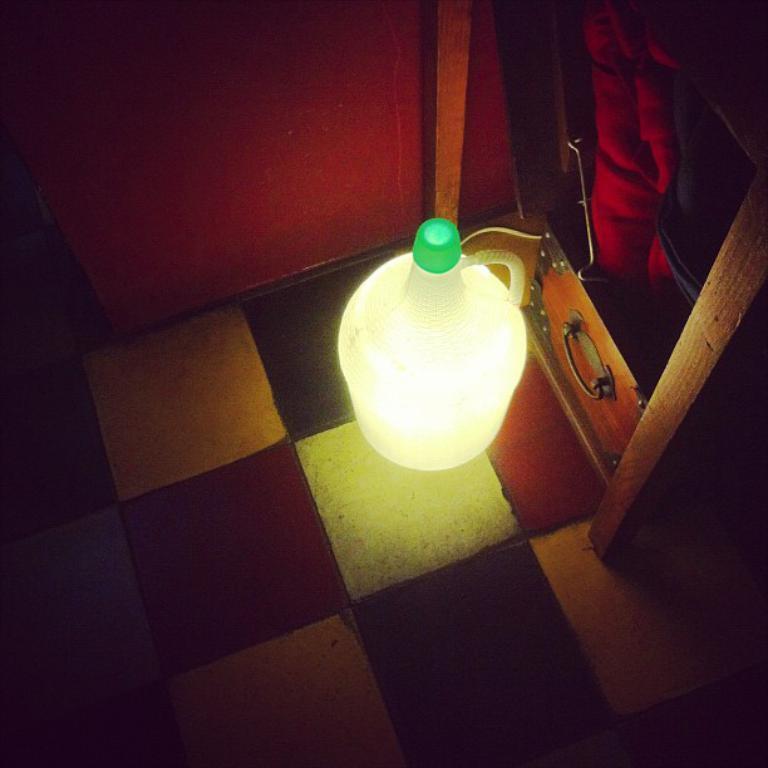Please provide a concise description of this image. In this image, we can see light, floor, wooden objects and few things. Here there is a wall. 